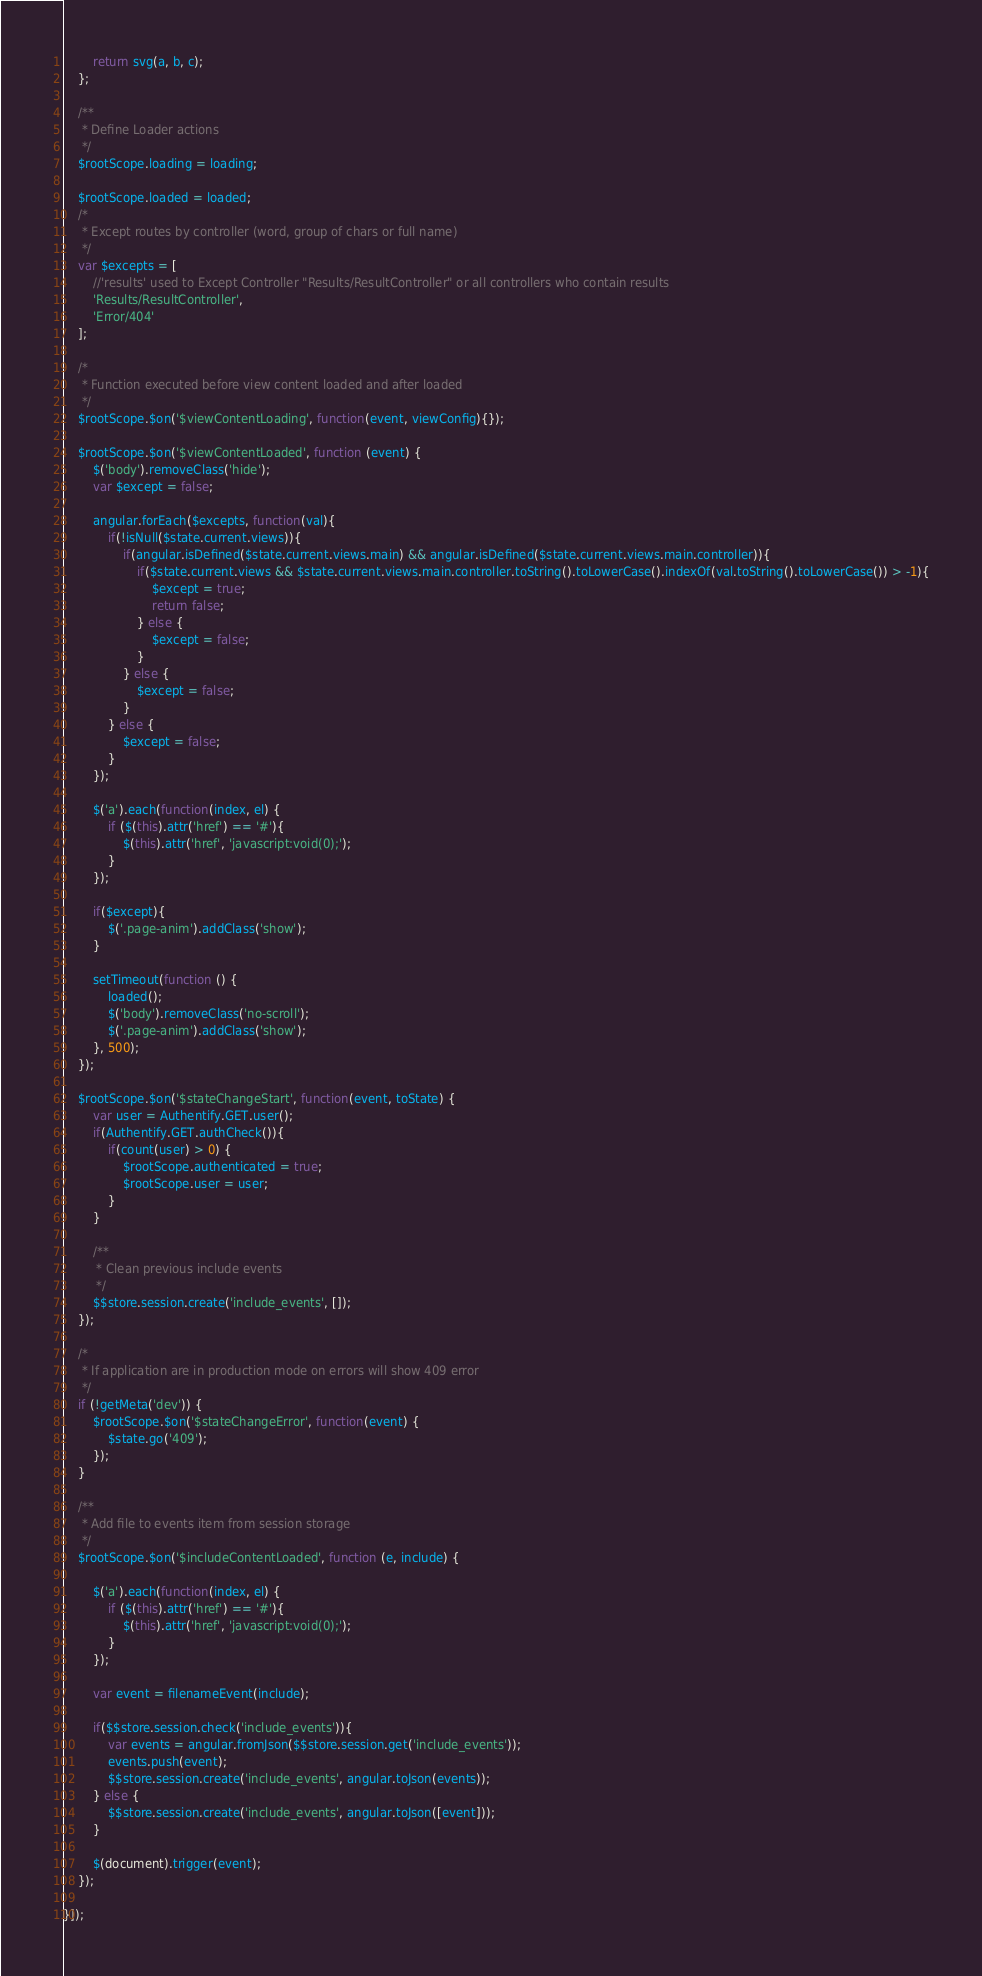Convert code to text. <code><loc_0><loc_0><loc_500><loc_500><_JavaScript_>        return svg(a, b, c);
    };

    /**
     * Define Loader actions
     */
    $rootScope.loading = loading;

    $rootScope.loaded = loaded;
    /*
     * Except routes by controller (word, group of chars or full name)
     */
    var $excepts = [
        //'results' used to Except Controller "Results/ResultController" or all controllers who contain results
        'Results/ResultController',
        'Error/404'
    ];

    /*
     * Function executed before view content loaded and after loaded
     */
    $rootScope.$on('$viewContentLoading', function(event, viewConfig){});

    $rootScope.$on('$viewContentLoaded', function (event) {
        $('body').removeClass('hide');
        var $except = false;

        angular.forEach($excepts, function(val){
            if(!isNull($state.current.views)){
                if(angular.isDefined($state.current.views.main) && angular.isDefined($state.current.views.main.controller)){
                    if($state.current.views && $state.current.views.main.controller.toString().toLowerCase().indexOf(val.toString().toLowerCase()) > -1){
                        $except = true;
                        return false;
                    } else {
                        $except = false;
                    }
                } else {
                    $except = false;
                }
            } else {
                $except = false;
            }
        });

        $('a').each(function(index, el) {
            if ($(this).attr('href') == '#'){
                $(this).attr('href', 'javascript:void(0);');
            }
        });

        if($except){
            $('.page-anim').addClass('show');
        }

        setTimeout(function () {
            loaded();
            $('body').removeClass('no-scroll');
            $('.page-anim').addClass('show');
        }, 500);
    });

    $rootScope.$on('$stateChangeStart', function(event, toState) {
        var user = Authentify.GET.user();
        if(Authentify.GET.authCheck()){
            if(count(user) > 0) {
                $rootScope.authenticated = true;
                $rootScope.user = user;
            }
        }

        /**
         * Clean previous include events
         */
        $$store.session.create('include_events', []);
    });

    /*
     * If application are in production mode on errors will show 409 error
     */
    if (!getMeta('dev')) {
        $rootScope.$on('$stateChangeError', function(event) {
            $state.go('409');
        });
    }

    /**
     * Add file to events item from session storage
     */
    $rootScope.$on('$includeContentLoaded', function (e, include) {

        $('a').each(function(index, el) {
            if ($(this).attr('href') == '#'){
                $(this).attr('href', 'javascript:void(0);');
            }
        });

        var event = filenameEvent(include);

        if($$store.session.check('include_events')){
            var events = angular.fromJson($$store.session.get('include_events'));
            events.push(event);
            $$store.session.create('include_events', angular.toJson(events));
        } else {
            $$store.session.create('include_events', angular.toJson([event]));
        }

        $(document).trigger(event);
    });

}]);
</code> 